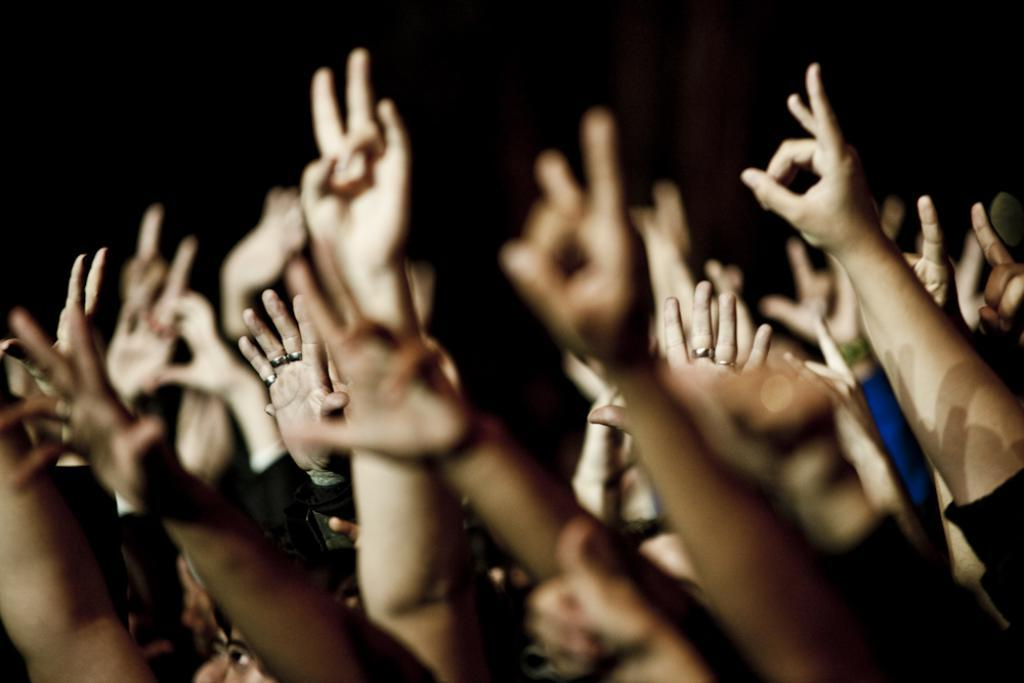How many people are in the group visible in the image? There is a group of people in the image, but the exact number cannot be determined without more specific information. What are the people in the group doing in the image? The people are raising their hands in the image. What is the color or lighting condition of the background in the image? The background of the image is dark. Can you see any curves on the toes of the people in the image? There is no reference to toes or curves on toes in the image, so it is not possible to answer that question. 